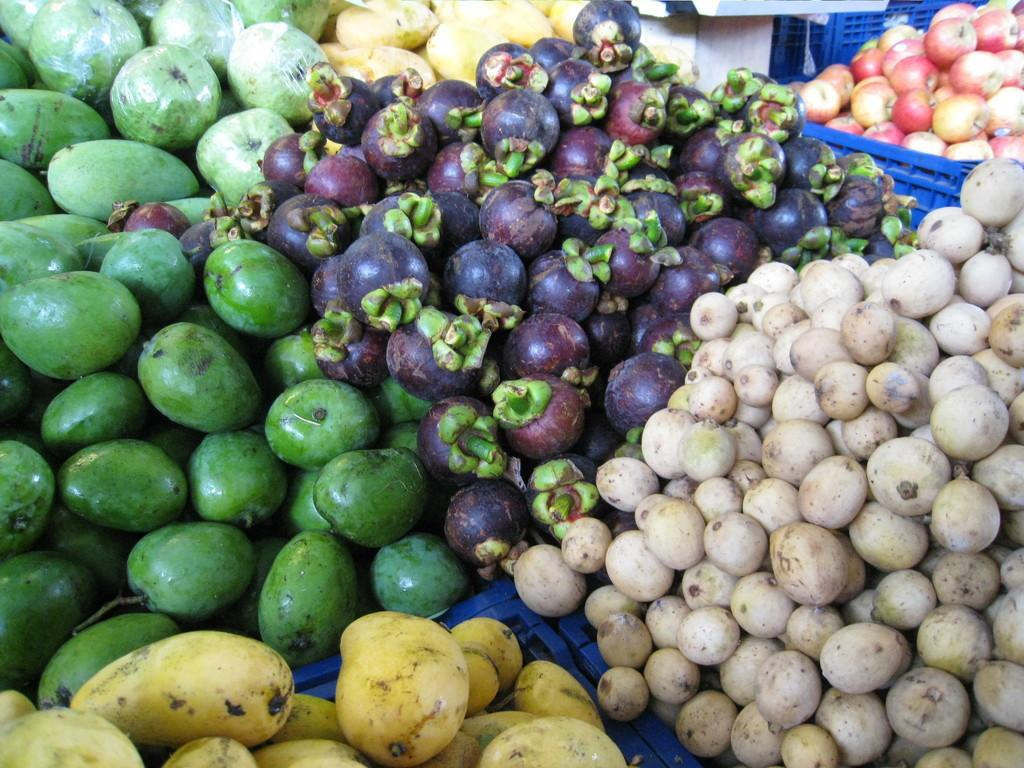What type of food can be seen in the image? There are fruits in the image. How are the fruits arranged or displayed in the image? The fruits are placed on containers. What type of pump is visible in the image? There is no pump present in the image; it features fruits placed on containers. What time does the clock show in the image? There is no clock present in the image. 